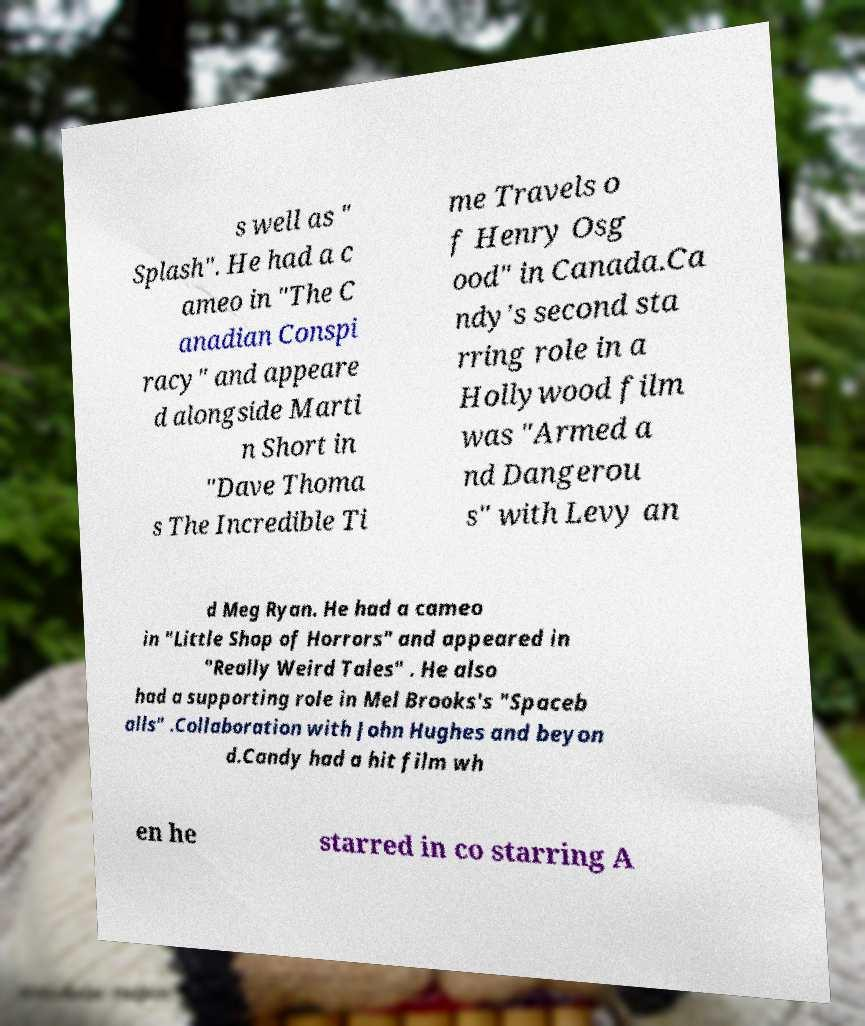I need the written content from this picture converted into text. Can you do that? s well as " Splash". He had a c ameo in "The C anadian Conspi racy" and appeare d alongside Marti n Short in "Dave Thoma s The Incredible Ti me Travels o f Henry Osg ood" in Canada.Ca ndy's second sta rring role in a Hollywood film was "Armed a nd Dangerou s" with Levy an d Meg Ryan. He had a cameo in "Little Shop of Horrors" and appeared in "Really Weird Tales" . He also had a supporting role in Mel Brooks's "Spaceb alls" .Collaboration with John Hughes and beyon d.Candy had a hit film wh en he starred in co starring A 